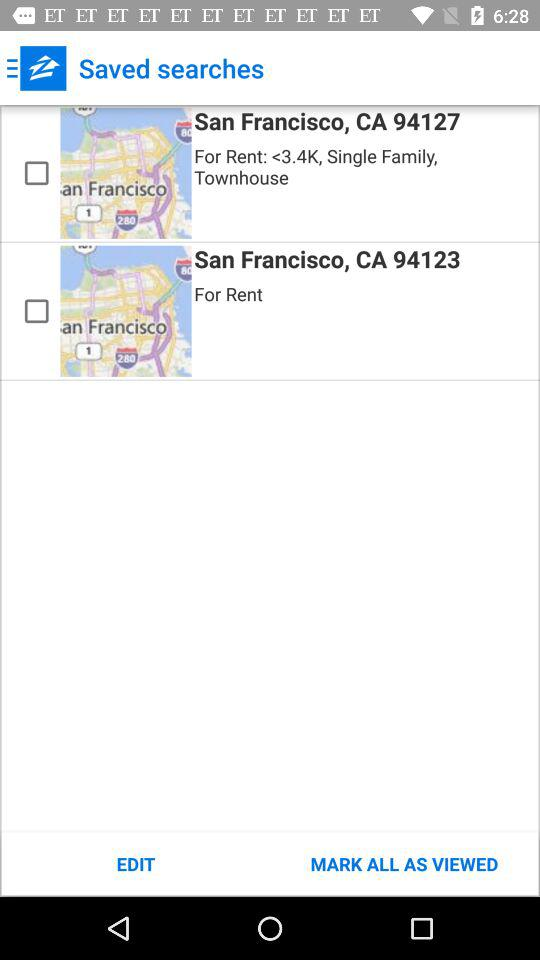How much is the rent for the first search?
Answer the question using a single word or phrase. <3.4K 